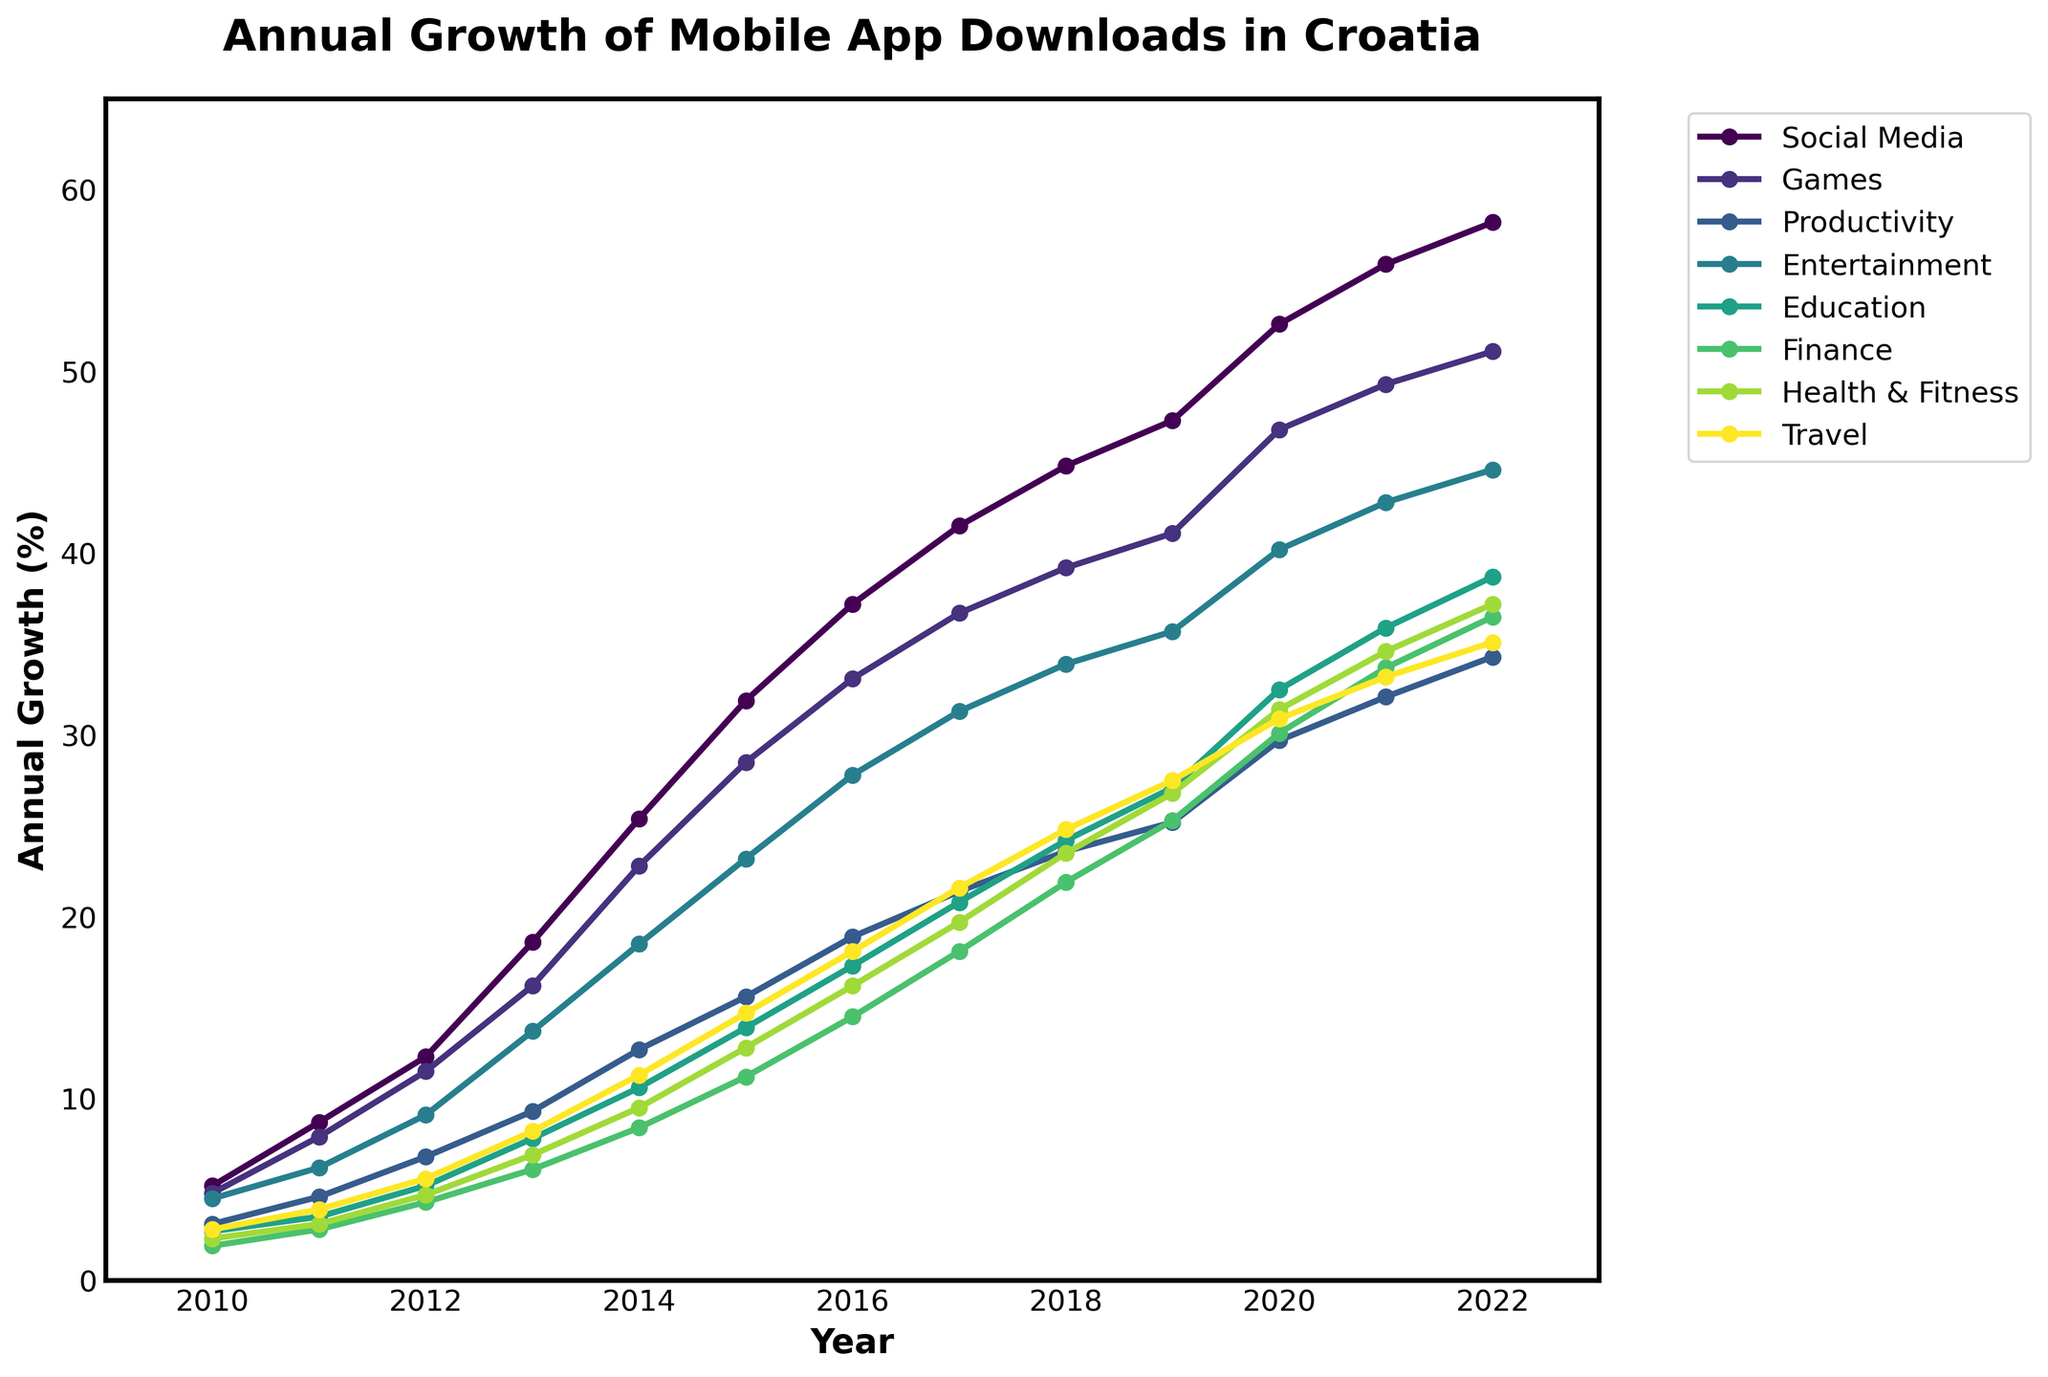What category saw the most significant growth in mobile app downloads from 2010 to 2022? The category with the most significant growth is determined by the largest increase in percentage from 2010 to 2022. By observing the figure, Social Media apps started at 5.2% in 2010 and reached 58.2% in 2022, which is the largest growth compared to other categories.
Answer: Social Media Which year did the "Games" category surpass the 30% mark in annual growth? Looking at the line for the "Games" category, the chart indicates that it first surpasses the 30% mark between 2015 and 2016. Specifically, in 2016 it reached 33.1%.
Answer: 2016 How much did the "Productivity" app downloads grow on average per year between 2010 and 2022? The average annual growth is calculated by summing the growth percentages from 2010 to 2022 and dividing by the number of years. Sum: 3.1 + 4.6 + 6.8 + 9.3 + 12.7 + 15.6 + 18.9 + 21.4 + 23.6 + 25.2 + 29.7 + 32.1 + 34.3 = 237.3. The average is 237.3 / 13 ≈ 18.25%.
Answer: 18.25% In which year did "Education" app downloads see the steepest rise compared to the previous year? The steepest rise is found by identifying the year-to-year differences. The rise from 2019 (27.1%) to 2020 (32.5%) is 32.5 - 27.1 = 5.4, which is the largest increase.
Answer: 2020 Compare the "Entertainment" and "Travel" categories' growth in 2015. Which one grew more and by how much? In 2015, Entertainment grew to 23.2% and Travel to 14.7%. The growth difference is 23.2 - 14.7 = 8.5%.
Answer: Entertainment by 8.5% Which category had the least growth in 2022, and what was its annual growth percentage? By locating the lowest point on the chart for 2022, we see that Finance had the least growth. Its percentage in 2022 was 36.5%.
Answer: Finance, 36.5% Compared to 2010, how many times more did "Health & Fitness" app downloads grow by 2020? In 2010, Health & Fitness was 2.3%, and by 2020 it was 31.4%. The growth factor is calculated as 31.4 / 2.3 ≈ 13.65.
Answer: 13.65 times What is the overall trend for the "Travel" app downloads from 2010 to 2022? Observing the "Travel" line, it shows a consistent upward trend from 2010 (2.8%) to 2022 (35.1%), indicating a steady increase each year.
Answer: Steady increase 